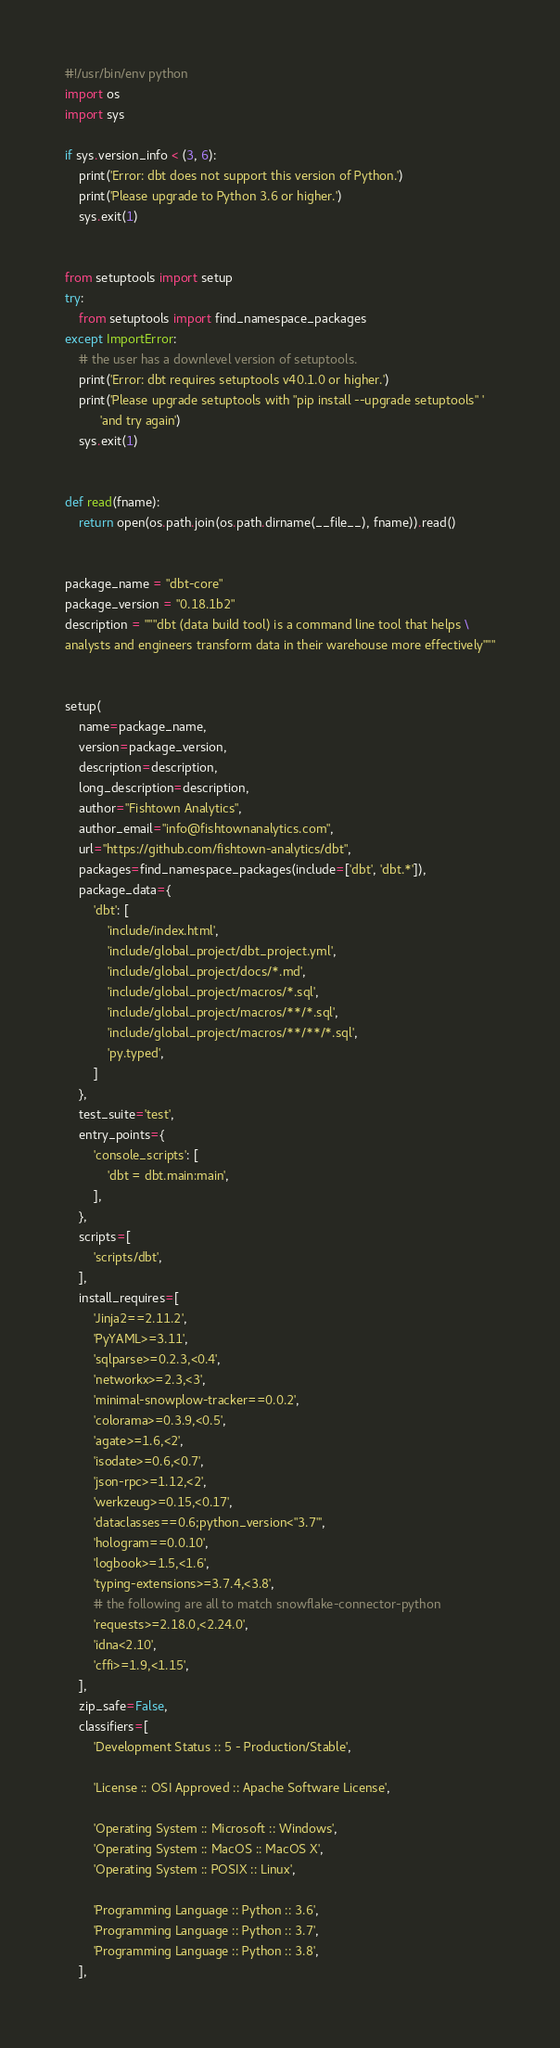<code> <loc_0><loc_0><loc_500><loc_500><_Python_>#!/usr/bin/env python
import os
import sys

if sys.version_info < (3, 6):
    print('Error: dbt does not support this version of Python.')
    print('Please upgrade to Python 3.6 or higher.')
    sys.exit(1)


from setuptools import setup
try:
    from setuptools import find_namespace_packages
except ImportError:
    # the user has a downlevel version of setuptools.
    print('Error: dbt requires setuptools v40.1.0 or higher.')
    print('Please upgrade setuptools with "pip install --upgrade setuptools" '
          'and try again')
    sys.exit(1)


def read(fname):
    return open(os.path.join(os.path.dirname(__file__), fname)).read()


package_name = "dbt-core"
package_version = "0.18.1b2"
description = """dbt (data build tool) is a command line tool that helps \
analysts and engineers transform data in their warehouse more effectively"""


setup(
    name=package_name,
    version=package_version,
    description=description,
    long_description=description,
    author="Fishtown Analytics",
    author_email="info@fishtownanalytics.com",
    url="https://github.com/fishtown-analytics/dbt",
    packages=find_namespace_packages(include=['dbt', 'dbt.*']),
    package_data={
        'dbt': [
            'include/index.html',
            'include/global_project/dbt_project.yml',
            'include/global_project/docs/*.md',
            'include/global_project/macros/*.sql',
            'include/global_project/macros/**/*.sql',
            'include/global_project/macros/**/**/*.sql',
            'py.typed',
        ]
    },
    test_suite='test',
    entry_points={
        'console_scripts': [
            'dbt = dbt.main:main',
        ],
    },
    scripts=[
        'scripts/dbt',
    ],
    install_requires=[
        'Jinja2==2.11.2',
        'PyYAML>=3.11',
        'sqlparse>=0.2.3,<0.4',
        'networkx>=2.3,<3',
        'minimal-snowplow-tracker==0.0.2',
        'colorama>=0.3.9,<0.5',
        'agate>=1.6,<2',
        'isodate>=0.6,<0.7',
        'json-rpc>=1.12,<2',
        'werkzeug>=0.15,<0.17',
        'dataclasses==0.6;python_version<"3.7"',
        'hologram==0.0.10',
        'logbook>=1.5,<1.6',
        'typing-extensions>=3.7.4,<3.8',
        # the following are all to match snowflake-connector-python
        'requests>=2.18.0,<2.24.0',
        'idna<2.10',
        'cffi>=1.9,<1.15',
    ],
    zip_safe=False,
    classifiers=[
        'Development Status :: 5 - Production/Stable',

        'License :: OSI Approved :: Apache Software License',

        'Operating System :: Microsoft :: Windows',
        'Operating System :: MacOS :: MacOS X',
        'Operating System :: POSIX :: Linux',

        'Programming Language :: Python :: 3.6',
        'Programming Language :: Python :: 3.7',
        'Programming Language :: Python :: 3.8',
    ],</code> 